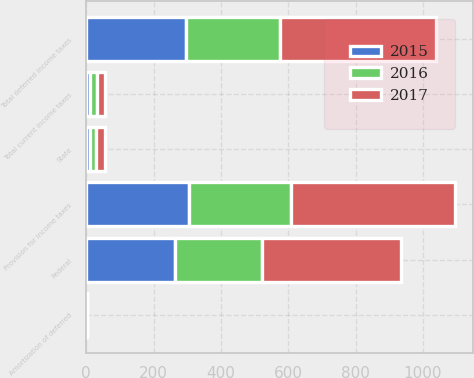Convert chart to OTSL. <chart><loc_0><loc_0><loc_500><loc_500><stacked_bar_chart><ecel><fcel>State<fcel>Total current income taxes<fcel>Federal<fcel>Amortization of deferred<fcel>Total deferred income taxes<fcel>Provision for income taxes<nl><fcel>2017<fcel>25<fcel>24<fcel>413<fcel>1<fcel>462<fcel>486<nl><fcel>2016<fcel>20<fcel>21<fcel>258<fcel>1<fcel>281<fcel>302<nl><fcel>2015<fcel>10<fcel>10<fcel>265<fcel>1<fcel>296<fcel>306<nl></chart> 